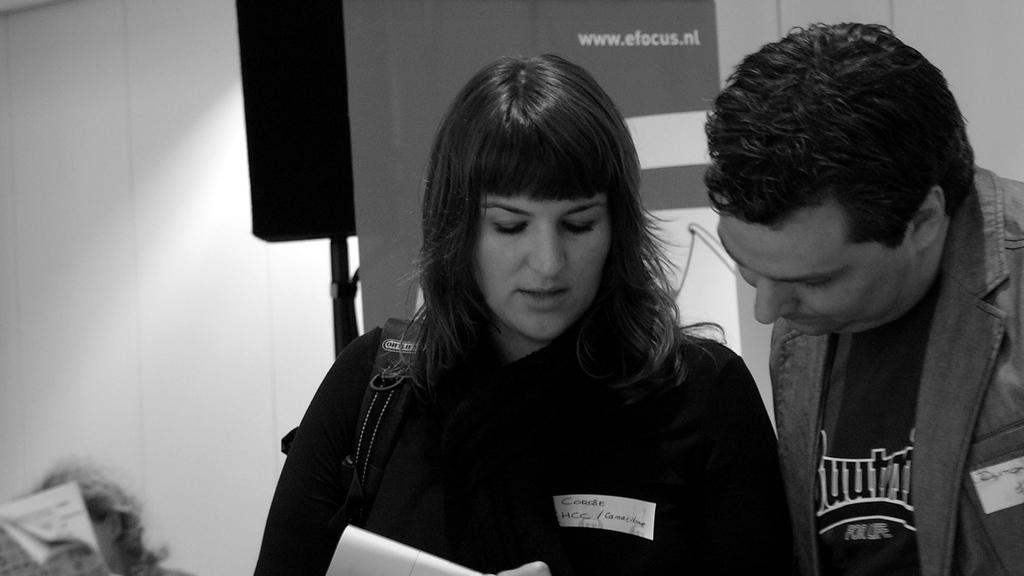<image>
Provide a brief description of the given image. A woman with HCC on a name tag is standing near a man. 